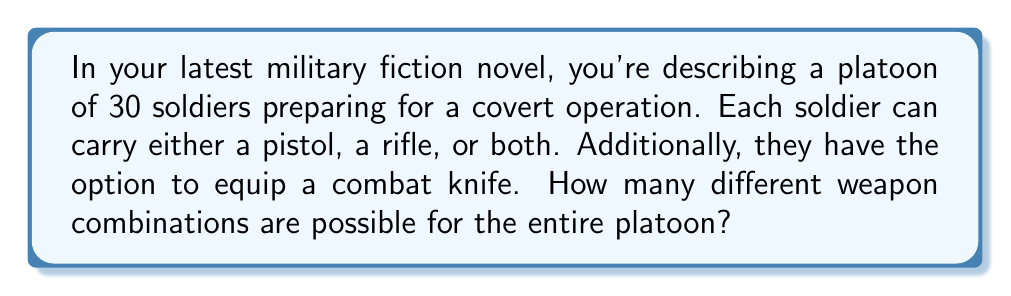Solve this math problem. Let's break this down step-by-step:

1) First, let's consider the options for each individual soldier:
   - Firearm options: pistol only, rifle only, both pistol and rifle, or no firearm
   - Knife option: with or without a knife

2) We can calculate the number of options for each soldier:
   - Firearm options: 4 choices
   - Knife option: 2 choices
   
   Total options per soldier: $4 \times 2 = 8$

3) Now, we need to determine how many ways these options can be distributed among the 30 soldiers in the platoon. This is a case of combinations with repetition.

4) The formula for combinations with repetition is:

   $${n+r-1 \choose r}$$

   Where $n$ is the number of types of items (in this case, 8 weapon combinations) and $r$ is the number of items being chosen (in this case, 30 soldiers).

5) Plugging in our values:

   $${8+30-1 \choose 30} = {37 \choose 30}$$

6) We can calculate this using the combination formula:

   $$\frac{37!}{30!(37-30)!} = \frac{37!}{30!7!}$$

7) This evaluates to:

   $$\frac{37 \times 36 \times 35 \times 34 \times 33 \times 32 \times 31}{7 \times 6 \times 5 \times 4 \times 3 \times 2 \times 1} = 10,295,472$$

Therefore, there are 10,295,472 different possible weapon combinations for the entire platoon.
Answer: 10,295,472 